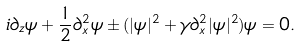Convert formula to latex. <formula><loc_0><loc_0><loc_500><loc_500>i \partial _ { z } \psi + \frac { 1 } { 2 } \partial _ { x } ^ { 2 } \psi \pm ( | \psi | ^ { 2 } + \gamma \partial _ { x } ^ { 2 } | \psi | ^ { 2 } ) \psi = 0 .</formula> 